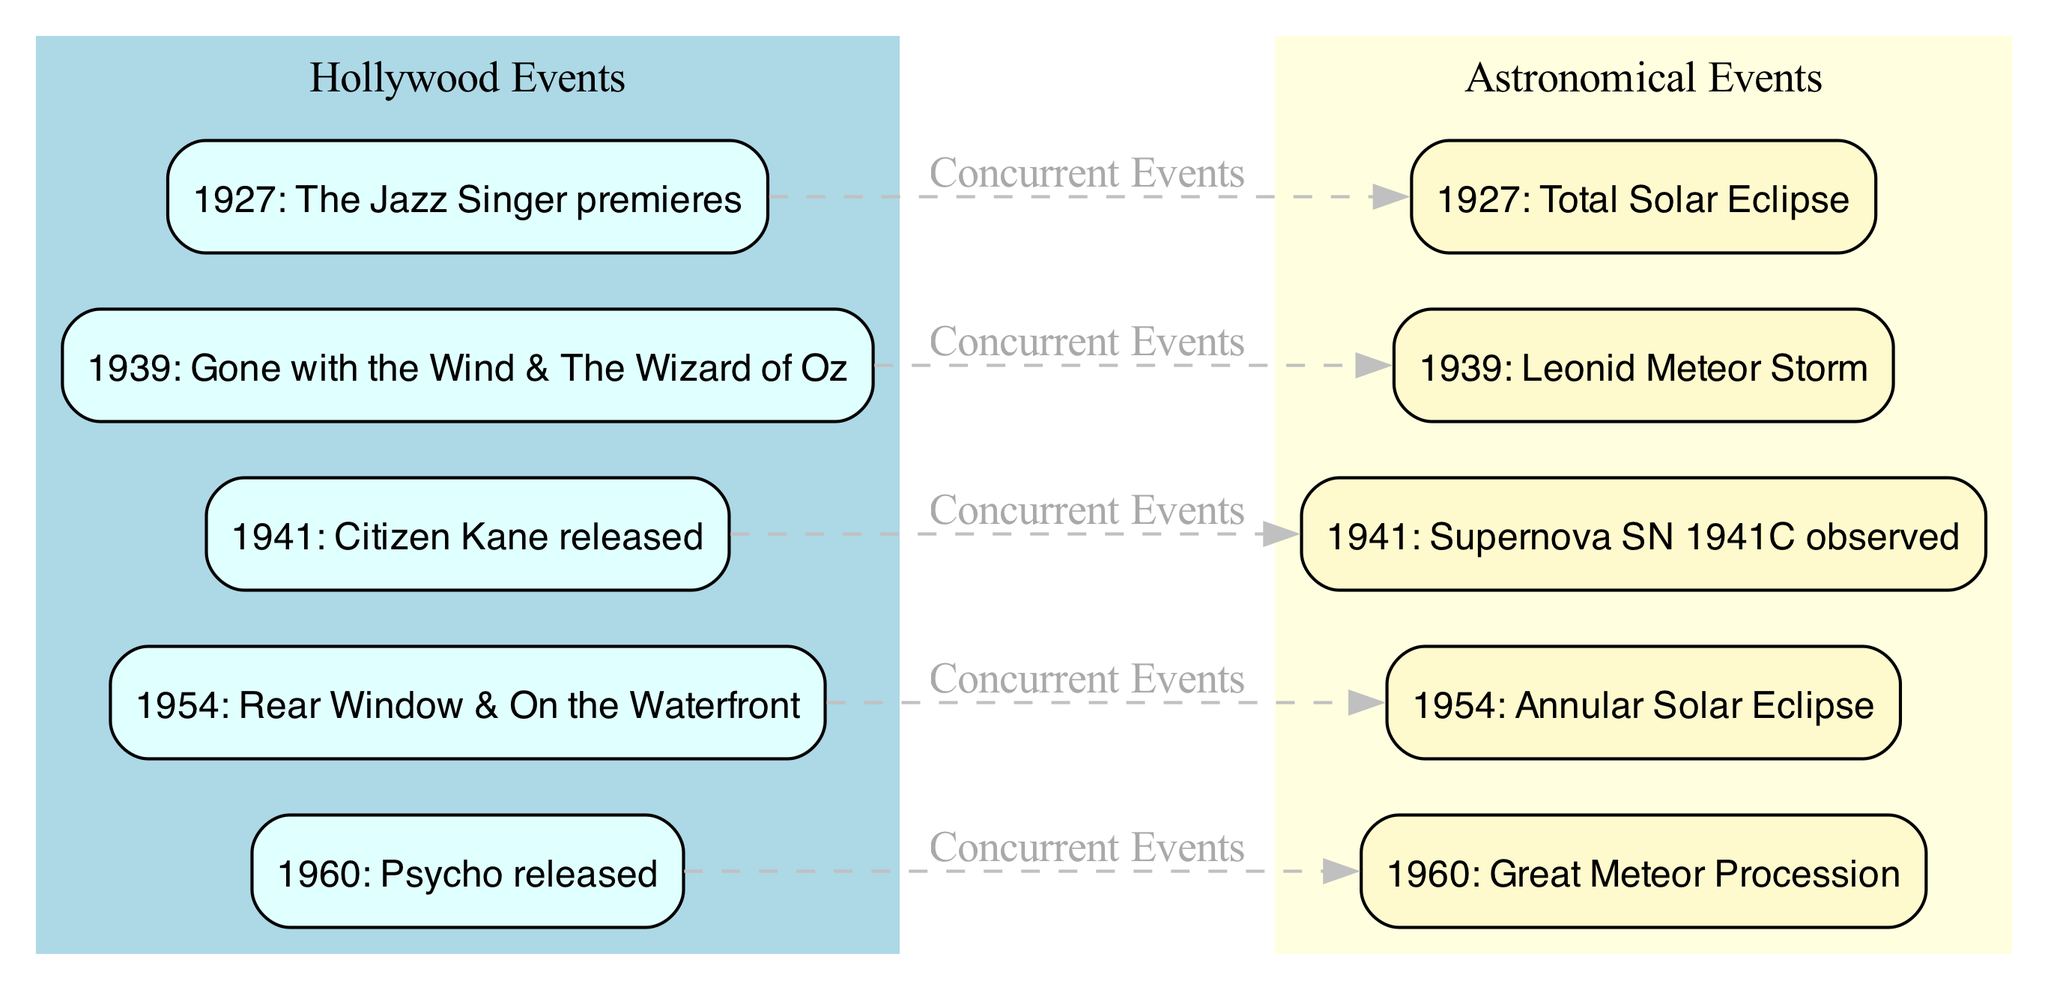What is the first movie listed in the Hollywood timeline? The diagram shows that the first movie listed is "The Jazz Singer premieres," which corresponds to the node labeled 1927: The Jazz Singer premieres.
Answer: The Jazz Singer premieres How many astronomical events are represented in the diagram? The diagram has five nodes categorized as astronomical events: a total solar eclipse in 1927, a Leonid meteor storm in 1939, a supernova observation in 1941, an annular solar eclipse in 1954, and a great meteor procession in 1960. This totals to five astronomical events.
Answer: Five Which Hollywood event corresponds to the 1941 astronomical event? The diagram shows an arrow connecting the node for the cinematic release of "Citizen Kane" in 1941 to the node for the observation of supernova SN 1941C, indicating their correlation.
Answer: Citizen Kane released What major documenting process occurs in 1960 according to the diagram? The diagram presents that in 1960, the significant Hollywood film released is "Psycho," which is indicated on the node. This correlates with a notable astronomical event labeled as the Great Meteor Procession.
Answer: Psycho released Which year saw both a movie premiere and a total solar eclipse? The diagram details that both the premiere of "The Jazz Singer" and the occurrence of the total solar eclipse took place in the same year, which is denoted as 1927.
Answer: 1927 What is the relationship between the 1939 Hollywood event and the astronomy event? The diagram represents a direct connection by a dashed edge labeled "Concurrent Events" between the node for the release of "Gone with the Wind & The Wizard of Oz" and the node for the Leonid Meteor Storm, illustrating that they occurred in parallel.
Answer: Concurrent Events Which year experienced an annular solar eclipse? The diagram clearly indicates the year 1954 as the time when the annular solar eclipse occurred, represented under the astronomical events category.
Answer: 1954 In how many instances do the significant Hollywood milestones align with concurrent astronomical events in this diagram? Upon reviewing the edges connecting Hollywood events to corresponding astronomical events, we observe a total of five instances where significant milestones align with celestial occurrences throughout the timeline presented in the diagram.
Answer: Five 